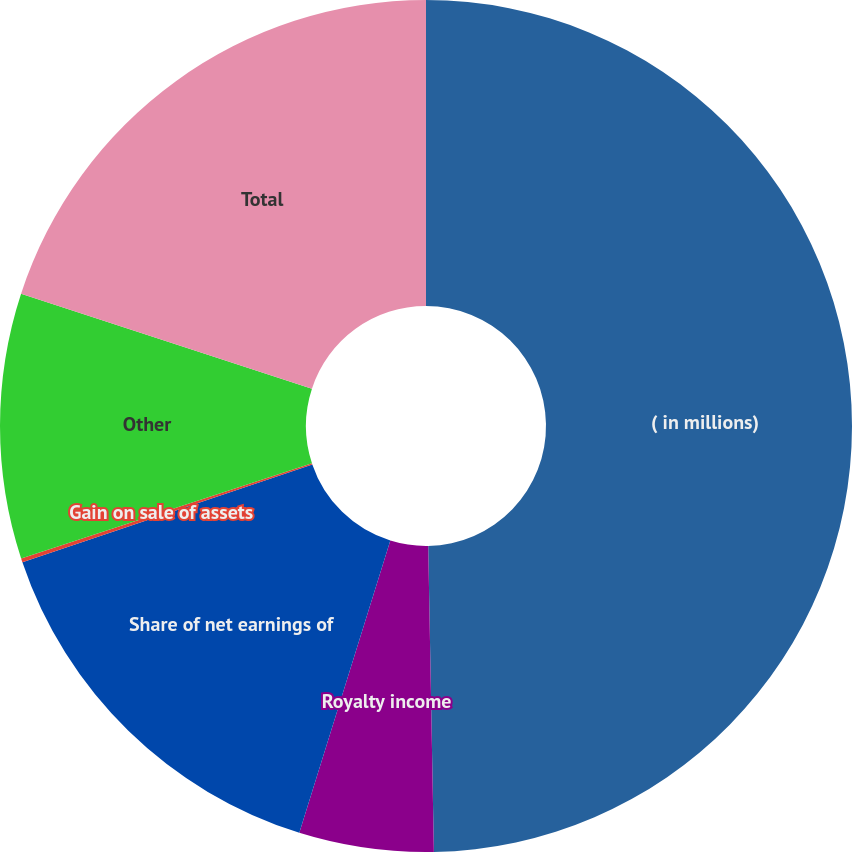Convert chart. <chart><loc_0><loc_0><loc_500><loc_500><pie_chart><fcel>( in millions)<fcel>Royalty income<fcel>Share of net earnings of<fcel>Gain on sale of assets<fcel>Other<fcel>Total<nl><fcel>49.7%<fcel>5.1%<fcel>15.01%<fcel>0.15%<fcel>10.06%<fcel>19.97%<nl></chart> 